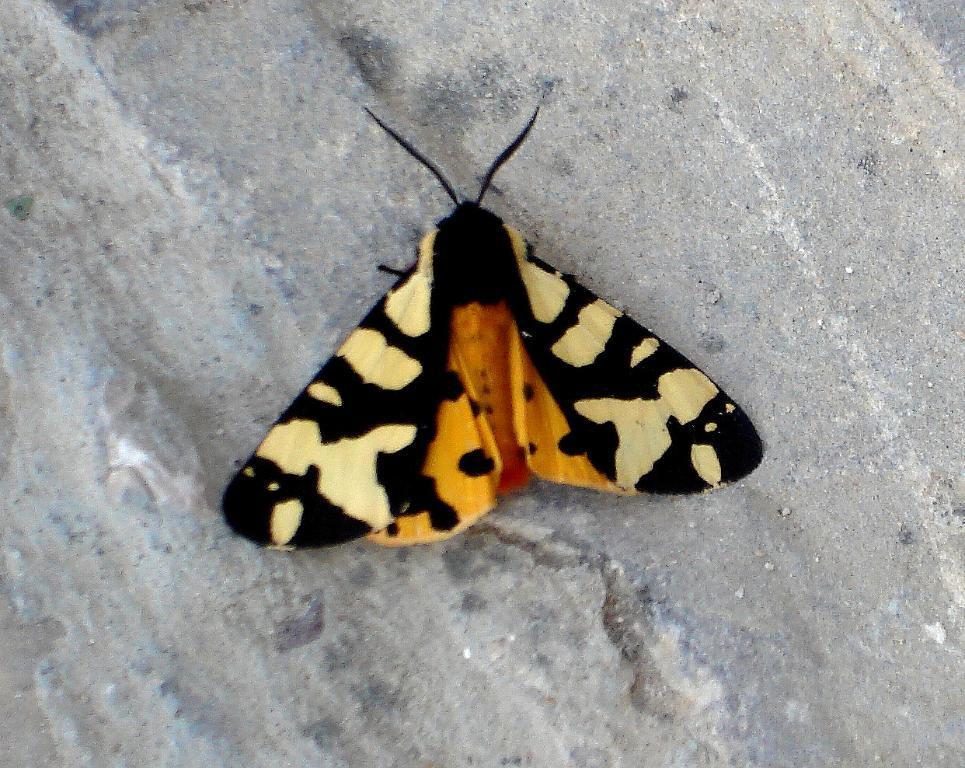Describe this image in one or two sentences. In the picture there is a butterfly represent. 